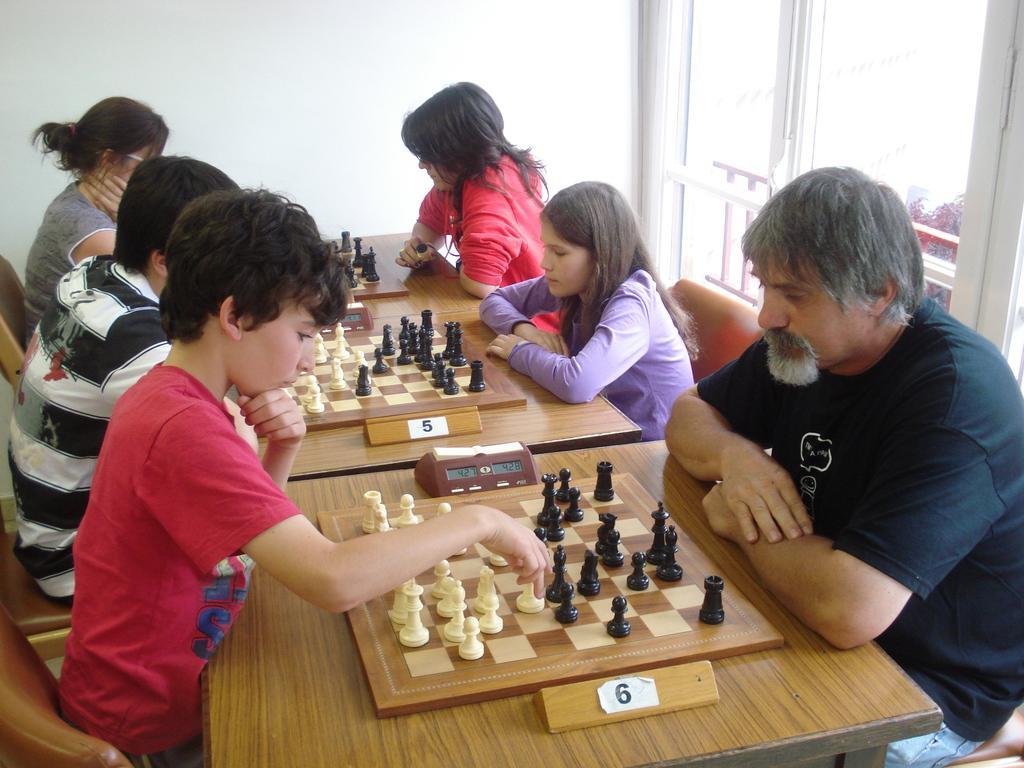In one or two sentences, can you explain what this image depicts? There are group of people playing chess in front of their opponents. 